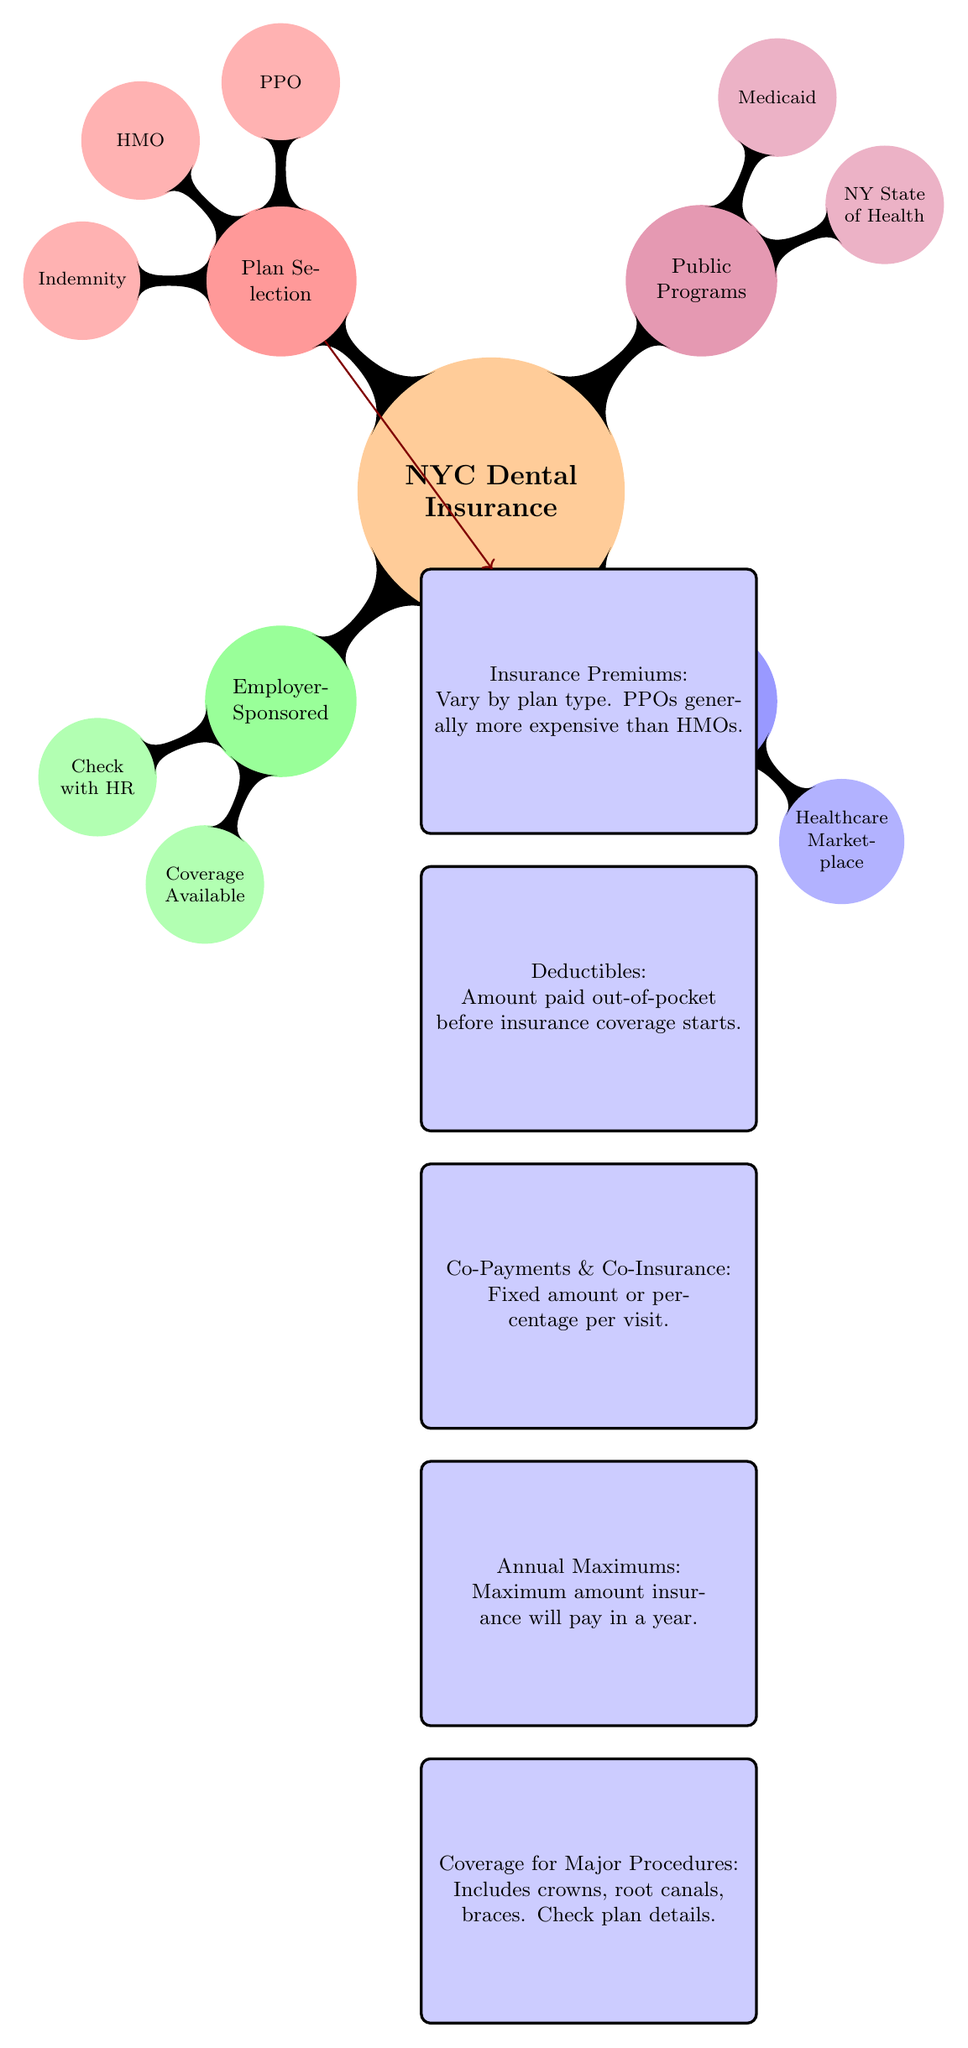What are the two main categories of dental insurance plans? The diagram indicates that the two main categories of dental insurance plans are Employer-Sponsored and Individual Plans. Each category is represented by a branch in the mind map structure.
Answer: Employer-Sponsored, Individual Plans How many public programs are listed in the diagram? In the Public Programs section of the diagram, two specific programs are named: NY State of Health and Medicaid. This can be counted directly in the diagram.
Answer: 2 Which type of plan generally costs more according to the diagram? The diagram states that PPOs generally cost more than HMOs, which is indicated in the Insurance Premiums node linked by an arrow from the Plan Selection node.
Answer: PPO What do you need to check with HR if you choose Employer-Sponsored insurance? The diagram shows that when considering Employer-Sponsored insurance, you should check with HR for potential coverage available. This is a direct statement from the respective node.
Answer: Check with HR What is the purpose of understanding deductibles according to the diagram? The diagram mentions that deductibles are the amount paid out-of-pocket before insurance coverage starts. This informs that understanding deductibles is important to know your initial expense before the insurance takes effect.
Answer: Amount paid out-of-pocket If someone selects an HMO plan, what might be a likely cost involved? Considering the structure of cost-related information in the diagram, a likely cost involved when selecting an HMO plan would be lower premiums compared to PPO. The diagram implies this relationship explicitly in the context of plan type costs.
Answer: Lower premiums What type of insurance is represented by the branch labeled "Plan Selection"? The "Plan Selection" branch of the diagram represents different insurance types such as PPO, HMO, and Indemnity, which are options available to choose from in the insurance landscape depicted.
Answer: PPO, HMO, Indemnity What is indicated regarding coverage for major procedures? The diagram indicates that coverage for major procedures includes items like crowns, root canals, and braces, and suggests checking the plan details for specific coverage information. This can be directly gleaned from the associated node in the diagram.
Answer: Includes crowns, root canals, braces 